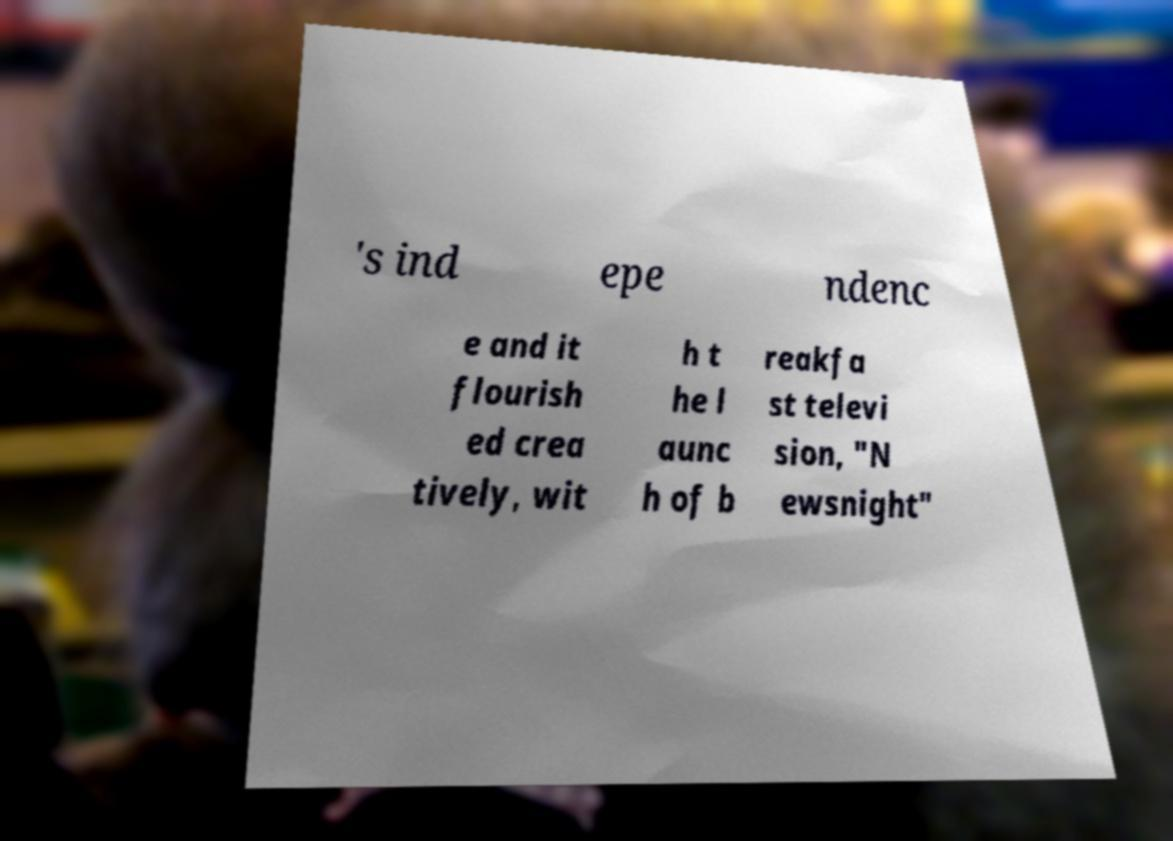Please read and relay the text visible in this image. What does it say? 's ind epe ndenc e and it flourish ed crea tively, wit h t he l aunc h of b reakfa st televi sion, "N ewsnight" 